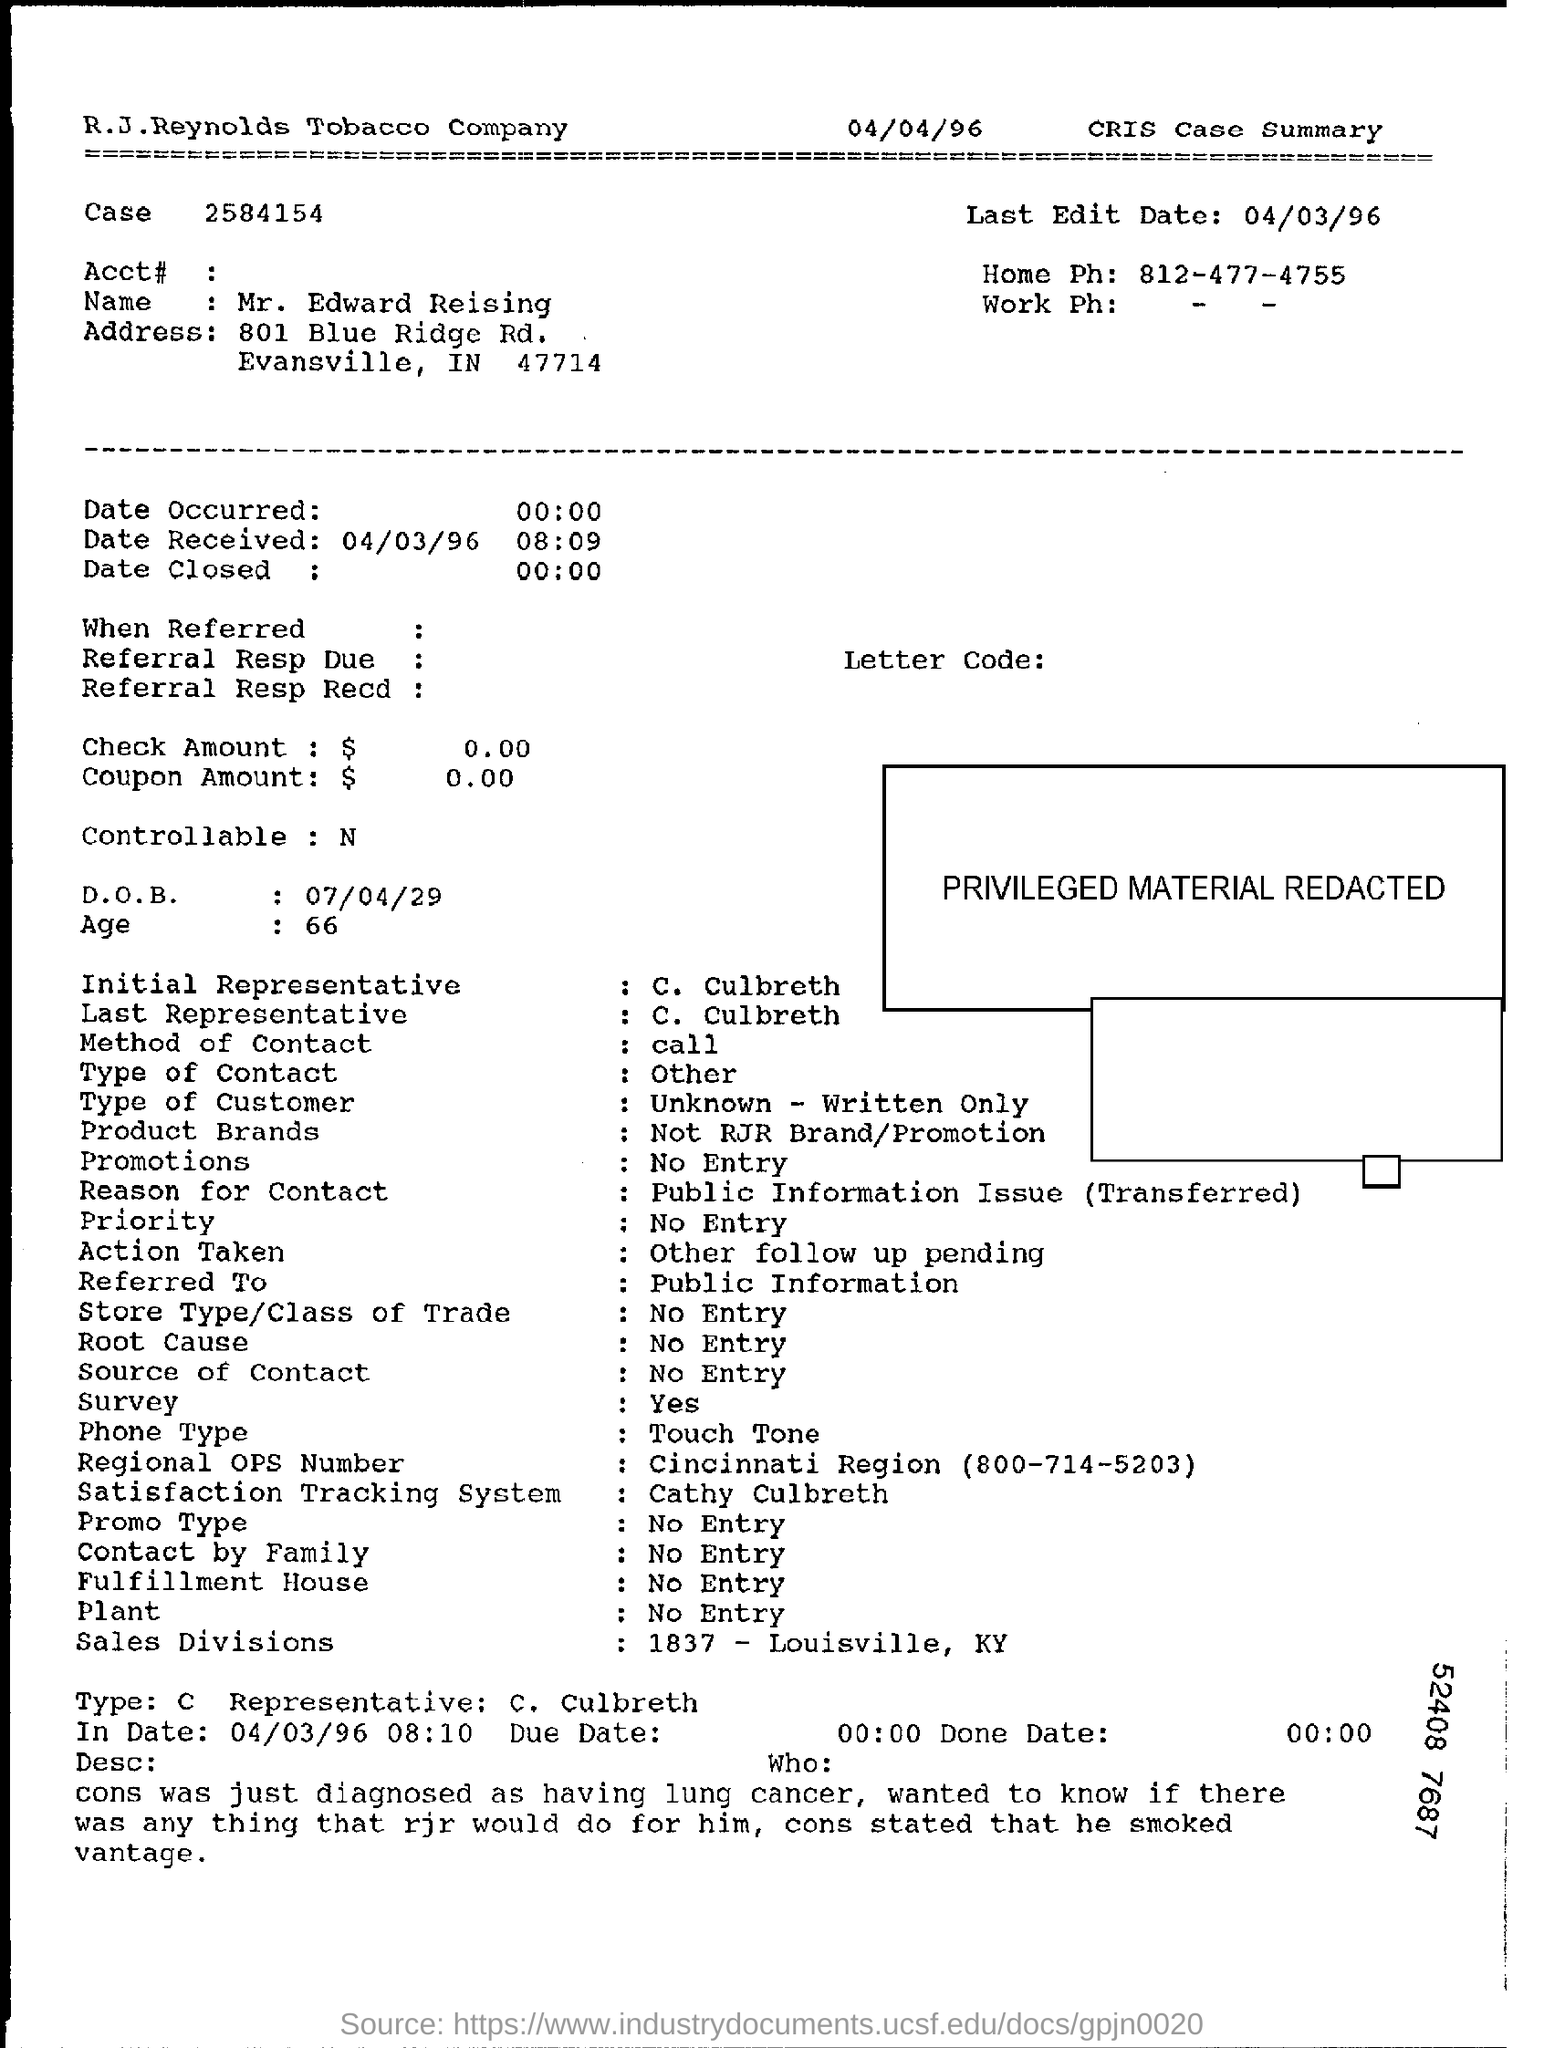What is the Name?
Your response must be concise. Mr. Edward Reising. What is the last Edit date?
Provide a succinct answer. 04/03/96. What is the Home Phone?
Your response must be concise. 812-477-4755. When is the date received?
Your answer should be compact. 04/03/96 08:09. What is the D.O.B?
Keep it short and to the point. 07/04/29. What is the age?
Keep it short and to the point. 66. Who is the initial representative?
Provide a succinct answer. C. Culbreth. Who is the last representative?
Provide a succinct answer. C. Culbreth. What is the reason for contact?
Keep it short and to the point. Public Information Issue (Transferred). What is the Regional OPS Number?
Your response must be concise. Cincinnati Region (800-714-5203). 